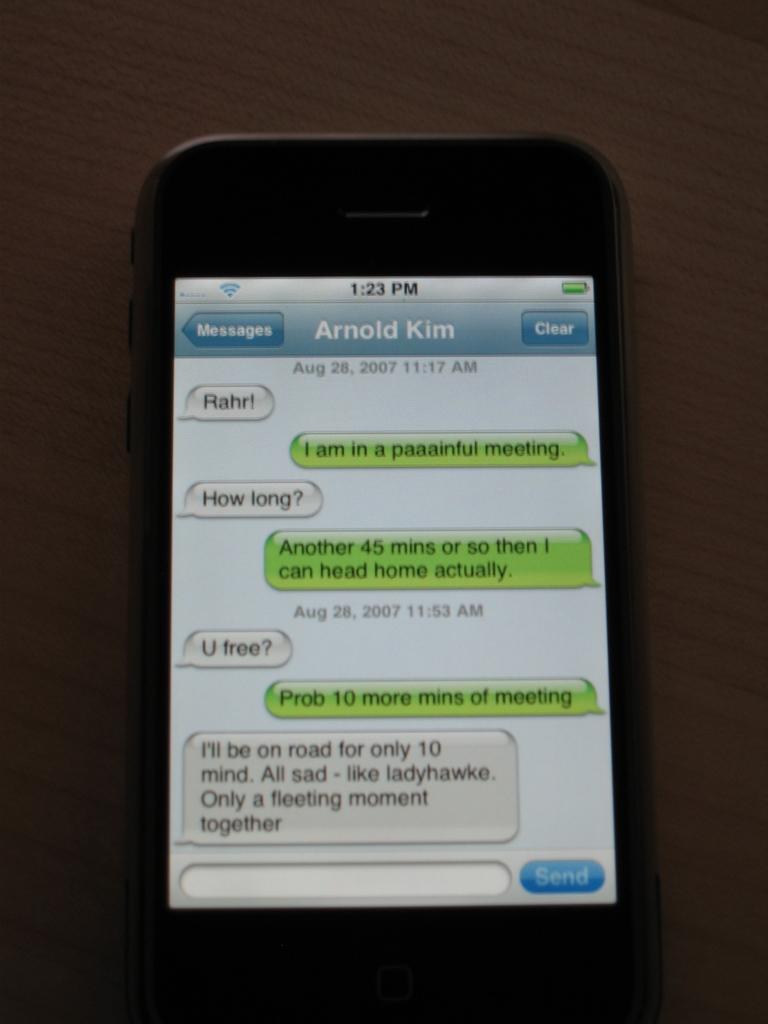How long does arnold have left in his meeting at the start of the conversation?
Make the answer very short. 45 minutes. What is arnold's last name?
Your response must be concise. Kim. 